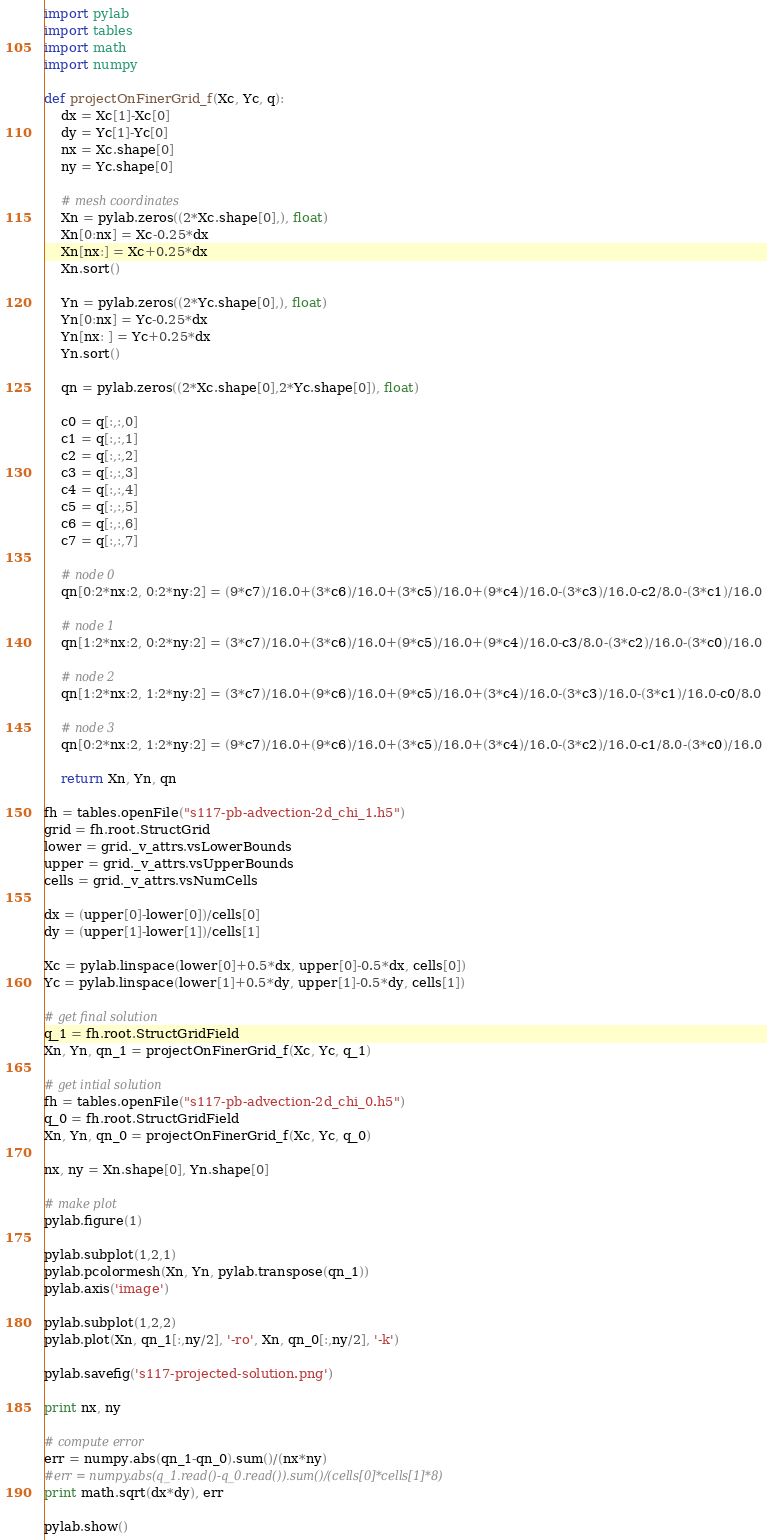<code> <loc_0><loc_0><loc_500><loc_500><_Python_>import pylab
import tables
import math
import numpy

def projectOnFinerGrid_f(Xc, Yc, q):
    dx = Xc[1]-Xc[0]
    dy = Yc[1]-Yc[0]
    nx = Xc.shape[0]
    ny = Yc.shape[0]

    # mesh coordinates
    Xn = pylab.zeros((2*Xc.shape[0],), float)
    Xn[0:nx] = Xc-0.25*dx
    Xn[nx:] = Xc+0.25*dx
    Xn.sort()

    Yn = pylab.zeros((2*Yc.shape[0],), float)
    Yn[0:nx] = Yc-0.25*dx
    Yn[nx: ] = Yc+0.25*dx
    Yn.sort()

    qn = pylab.zeros((2*Xc.shape[0],2*Yc.shape[0]), float)

    c0 = q[:,:,0]
    c1 = q[:,:,1]
    c2 = q[:,:,2]
    c3 = q[:,:,3]
    c4 = q[:,:,4]
    c5 = q[:,:,5]
    c6 = q[:,:,6]
    c7 = q[:,:,7]

    # node 0
    qn[0:2*nx:2, 0:2*ny:2] = (9*c7)/16.0+(3*c6)/16.0+(3*c5)/16.0+(9*c4)/16.0-(3*c3)/16.0-c2/8.0-(3*c1)/16.0

    # node 1
    qn[1:2*nx:2, 0:2*ny:2] = (3*c7)/16.0+(3*c6)/16.0+(9*c5)/16.0+(9*c4)/16.0-c3/8.0-(3*c2)/16.0-(3*c0)/16.0

    # node 2
    qn[1:2*nx:2, 1:2*ny:2] = (3*c7)/16.0+(9*c6)/16.0+(9*c5)/16.0+(3*c4)/16.0-(3*c3)/16.0-(3*c1)/16.0-c0/8.0

    # node 3
    qn[0:2*nx:2, 1:2*ny:2] = (9*c7)/16.0+(9*c6)/16.0+(3*c5)/16.0+(3*c4)/16.0-(3*c2)/16.0-c1/8.0-(3*c0)/16.0

    return Xn, Yn, qn

fh = tables.openFile("s117-pb-advection-2d_chi_1.h5")
grid = fh.root.StructGrid
lower = grid._v_attrs.vsLowerBounds
upper = grid._v_attrs.vsUpperBounds
cells = grid._v_attrs.vsNumCells

dx = (upper[0]-lower[0])/cells[0]
dy = (upper[1]-lower[1])/cells[1]

Xc = pylab.linspace(lower[0]+0.5*dx, upper[0]-0.5*dx, cells[0])
Yc = pylab.linspace(lower[1]+0.5*dy, upper[1]-0.5*dy, cells[1])

# get final solution
q_1 = fh.root.StructGridField
Xn, Yn, qn_1 = projectOnFinerGrid_f(Xc, Yc, q_1)

# get intial solution
fh = tables.openFile("s117-pb-advection-2d_chi_0.h5")
q_0 = fh.root.StructGridField
Xn, Yn, qn_0 = projectOnFinerGrid_f(Xc, Yc, q_0)

nx, ny = Xn.shape[0], Yn.shape[0]

# make plot
pylab.figure(1)

pylab.subplot(1,2,1)
pylab.pcolormesh(Xn, Yn, pylab.transpose(qn_1))
pylab.axis('image')

pylab.subplot(1,2,2)
pylab.plot(Xn, qn_1[:,ny/2], '-ro', Xn, qn_0[:,ny/2], '-k')

pylab.savefig('s117-projected-solution.png')

print nx, ny

# compute error
err = numpy.abs(qn_1-qn_0).sum()/(nx*ny)
#err = numpy.abs(q_1.read()-q_0.read()).sum()/(cells[0]*cells[1]*8)
print math.sqrt(dx*dy), err

pylab.show()
</code> 